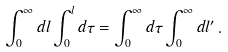<formula> <loc_0><loc_0><loc_500><loc_500>\int _ { 0 } ^ { \infty } d l \int _ { 0 } ^ { l } d \tau = \int _ { 0 } ^ { \infty } d \tau \int _ { 0 } ^ { \infty } d l ^ { \prime } \, .</formula> 